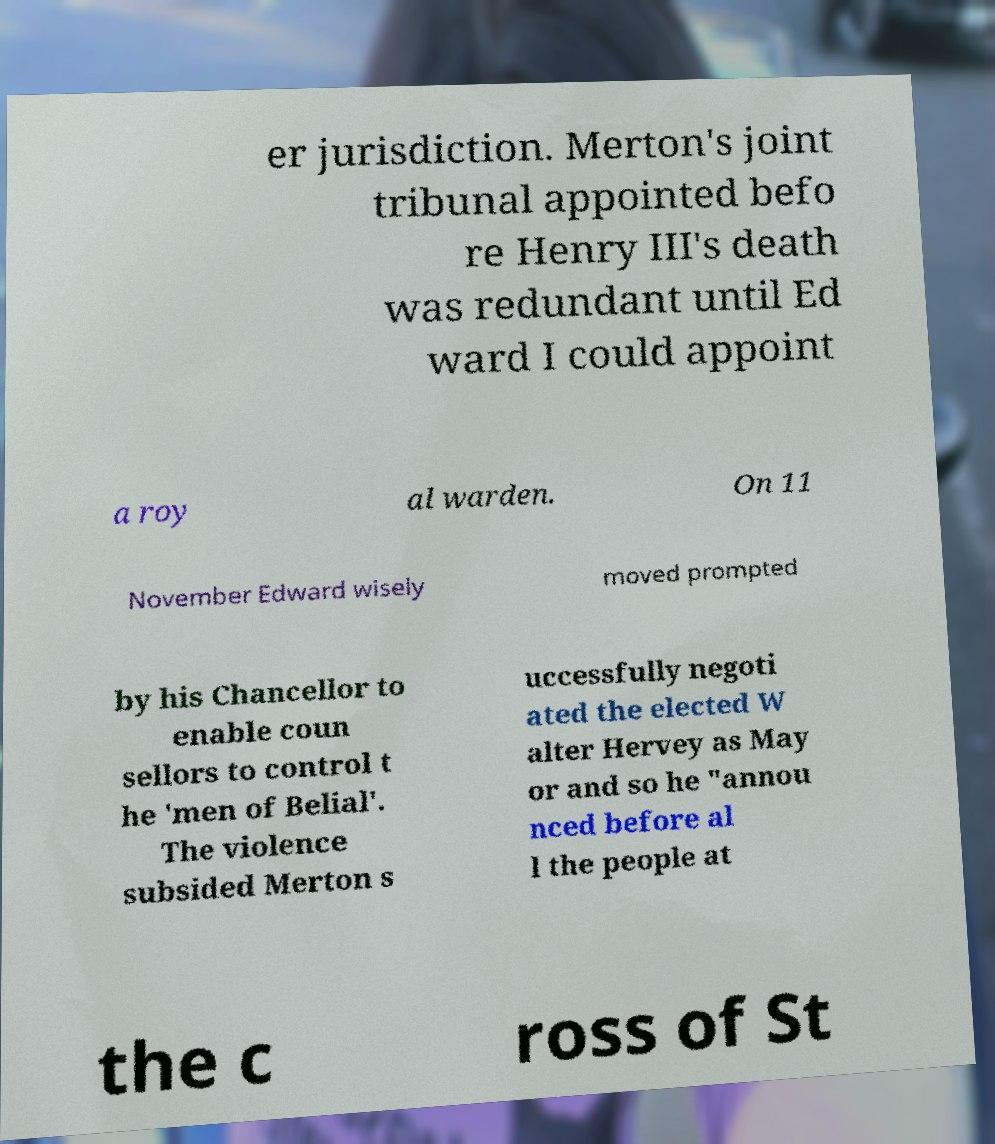Could you extract and type out the text from this image? er jurisdiction. Merton's joint tribunal appointed befo re Henry III's death was redundant until Ed ward I could appoint a roy al warden. On 11 November Edward wisely moved prompted by his Chancellor to enable coun sellors to control t he 'men of Belial'. The violence subsided Merton s uccessfully negoti ated the elected W alter Hervey as May or and so he "annou nced before al l the people at the c ross of St 